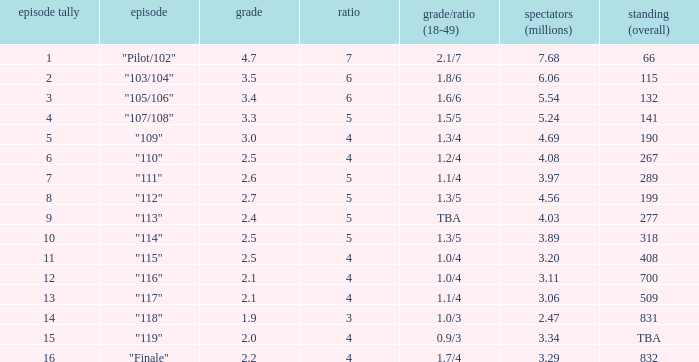WHAT IS THE RATING THAT HAD A SHARE SMALLER THAN 4, AND 2.47 MILLION VIEWERS? 0.0. 